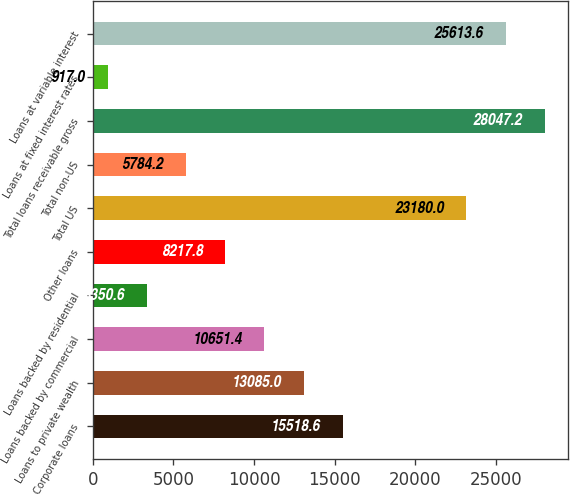Convert chart to OTSL. <chart><loc_0><loc_0><loc_500><loc_500><bar_chart><fcel>Corporate loans<fcel>Loans to private wealth<fcel>Loans backed by commercial<fcel>Loans backed by residential<fcel>Other loans<fcel>Total US<fcel>Total non-US<fcel>Total loans receivable gross<fcel>Loans at fixed interest rates<fcel>Loans at variable interest<nl><fcel>15518.6<fcel>13085<fcel>10651.4<fcel>3350.6<fcel>8217.8<fcel>23180<fcel>5784.2<fcel>28047.2<fcel>917<fcel>25613.6<nl></chart> 